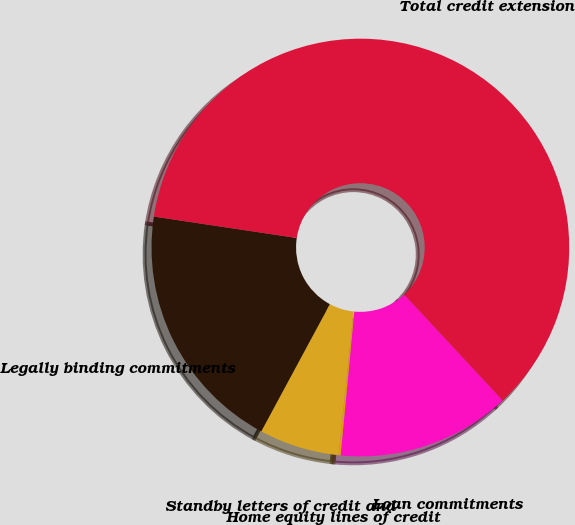Convert chart to OTSL. <chart><loc_0><loc_0><loc_500><loc_500><pie_chart><fcel>Loan commitments<fcel>Home equity lines of credit<fcel>Standby letters of credit and<fcel>Legally binding commitments<fcel>Total credit extension<nl><fcel>13.44%<fcel>0.15%<fcel>6.21%<fcel>19.5%<fcel>60.71%<nl></chart> 